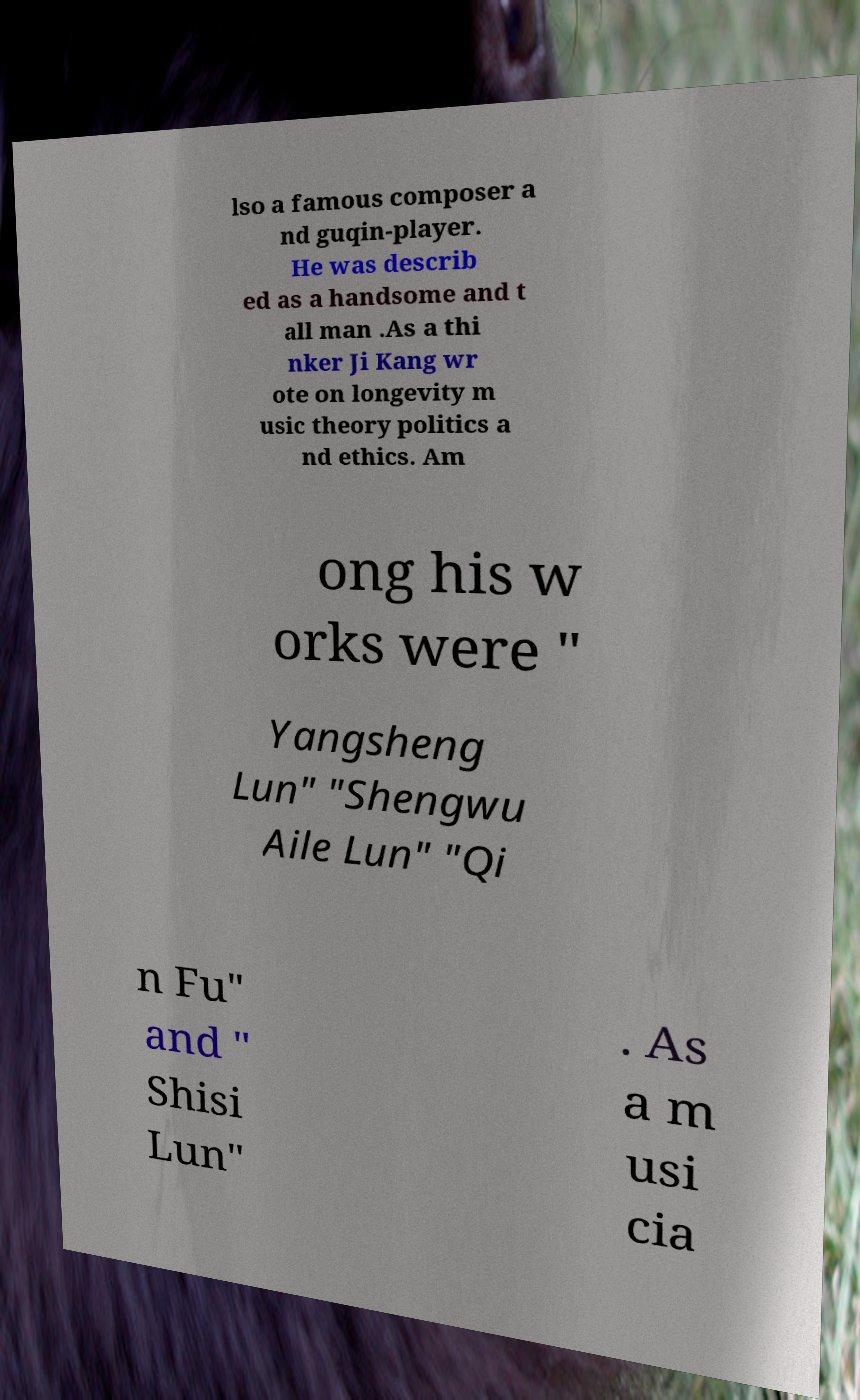Could you assist in decoding the text presented in this image and type it out clearly? lso a famous composer a nd guqin-player. He was describ ed as a handsome and t all man .As a thi nker Ji Kang wr ote on longevity m usic theory politics a nd ethics. Am ong his w orks were " Yangsheng Lun" "Shengwu Aile Lun" "Qi n Fu" and " Shisi Lun" . As a m usi cia 